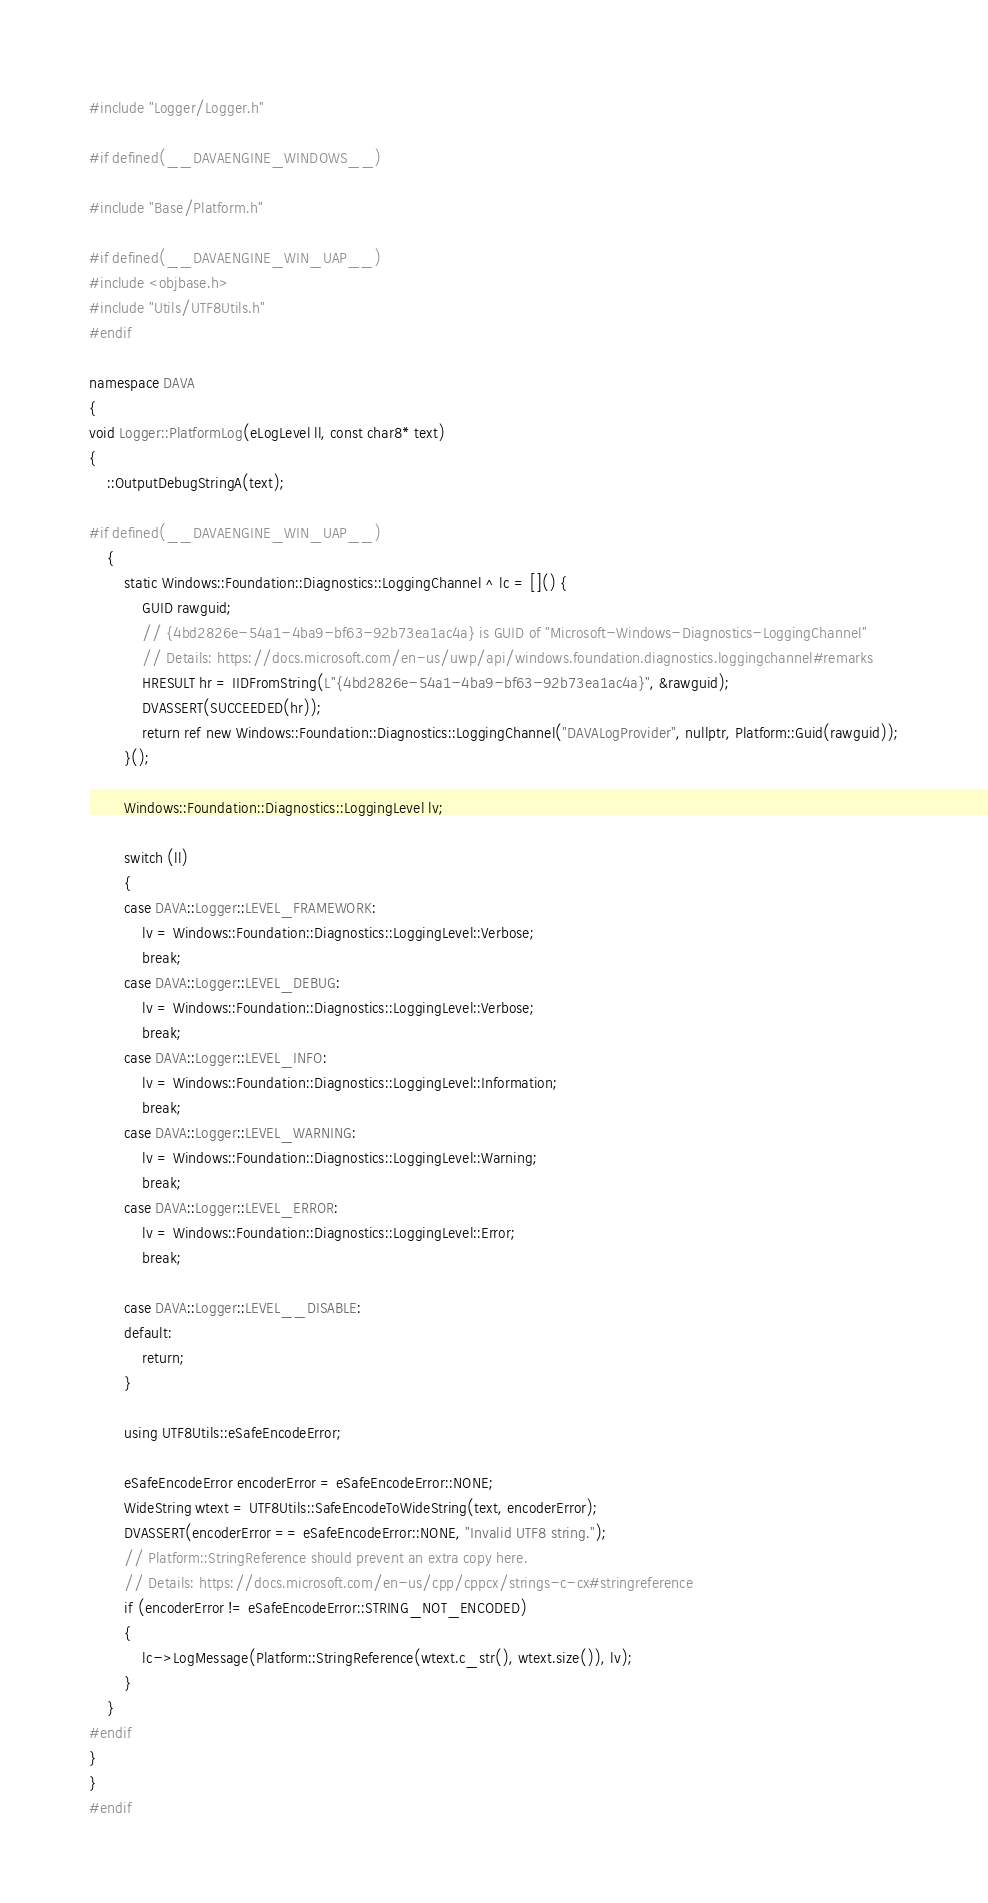<code> <loc_0><loc_0><loc_500><loc_500><_C++_>#include "Logger/Logger.h"

#if defined(__DAVAENGINE_WINDOWS__)

#include "Base/Platform.h"

#if defined(__DAVAENGINE_WIN_UAP__)
#include <objbase.h>
#include "Utils/UTF8Utils.h"
#endif

namespace DAVA
{
void Logger::PlatformLog(eLogLevel ll, const char8* text)
{
    ::OutputDebugStringA(text);

#if defined(__DAVAENGINE_WIN_UAP__)
    {
        static Windows::Foundation::Diagnostics::LoggingChannel ^ lc = []() {
            GUID rawguid;
            // {4bd2826e-54a1-4ba9-bf63-92b73ea1ac4a} is GUID of "Microsoft-Windows-Diagnostics-LoggingChannel"
            // Details: https://docs.microsoft.com/en-us/uwp/api/windows.foundation.diagnostics.loggingchannel#remarks
            HRESULT hr = IIDFromString(L"{4bd2826e-54a1-4ba9-bf63-92b73ea1ac4a}", &rawguid);
            DVASSERT(SUCCEEDED(hr));
            return ref new Windows::Foundation::Diagnostics::LoggingChannel("DAVALogProvider", nullptr, Platform::Guid(rawguid));
        }();

        Windows::Foundation::Diagnostics::LoggingLevel lv;

        switch (ll)
        {
        case DAVA::Logger::LEVEL_FRAMEWORK:
            lv = Windows::Foundation::Diagnostics::LoggingLevel::Verbose;
            break;
        case DAVA::Logger::LEVEL_DEBUG:
            lv = Windows::Foundation::Diagnostics::LoggingLevel::Verbose;
            break;
        case DAVA::Logger::LEVEL_INFO:
            lv = Windows::Foundation::Diagnostics::LoggingLevel::Information;
            break;
        case DAVA::Logger::LEVEL_WARNING:
            lv = Windows::Foundation::Diagnostics::LoggingLevel::Warning;
            break;
        case DAVA::Logger::LEVEL_ERROR:
            lv = Windows::Foundation::Diagnostics::LoggingLevel::Error;
            break;

        case DAVA::Logger::LEVEL__DISABLE:
        default:
            return;
        }

        using UTF8Utils::eSafeEncodeError;

        eSafeEncodeError encoderError = eSafeEncodeError::NONE;
        WideString wtext = UTF8Utils::SafeEncodeToWideString(text, encoderError);
        DVASSERT(encoderError == eSafeEncodeError::NONE, "Invalid UTF8 string.");
        // Platform::StringReference should prevent an extra copy here.
        // Details: https://docs.microsoft.com/en-us/cpp/cppcx/strings-c-cx#stringreference
        if (encoderError != eSafeEncodeError::STRING_NOT_ENCODED)
        {
            lc->LogMessage(Platform::StringReference(wtext.c_str(), wtext.size()), lv);
        }
    }
#endif
}
}
#endif
</code> 